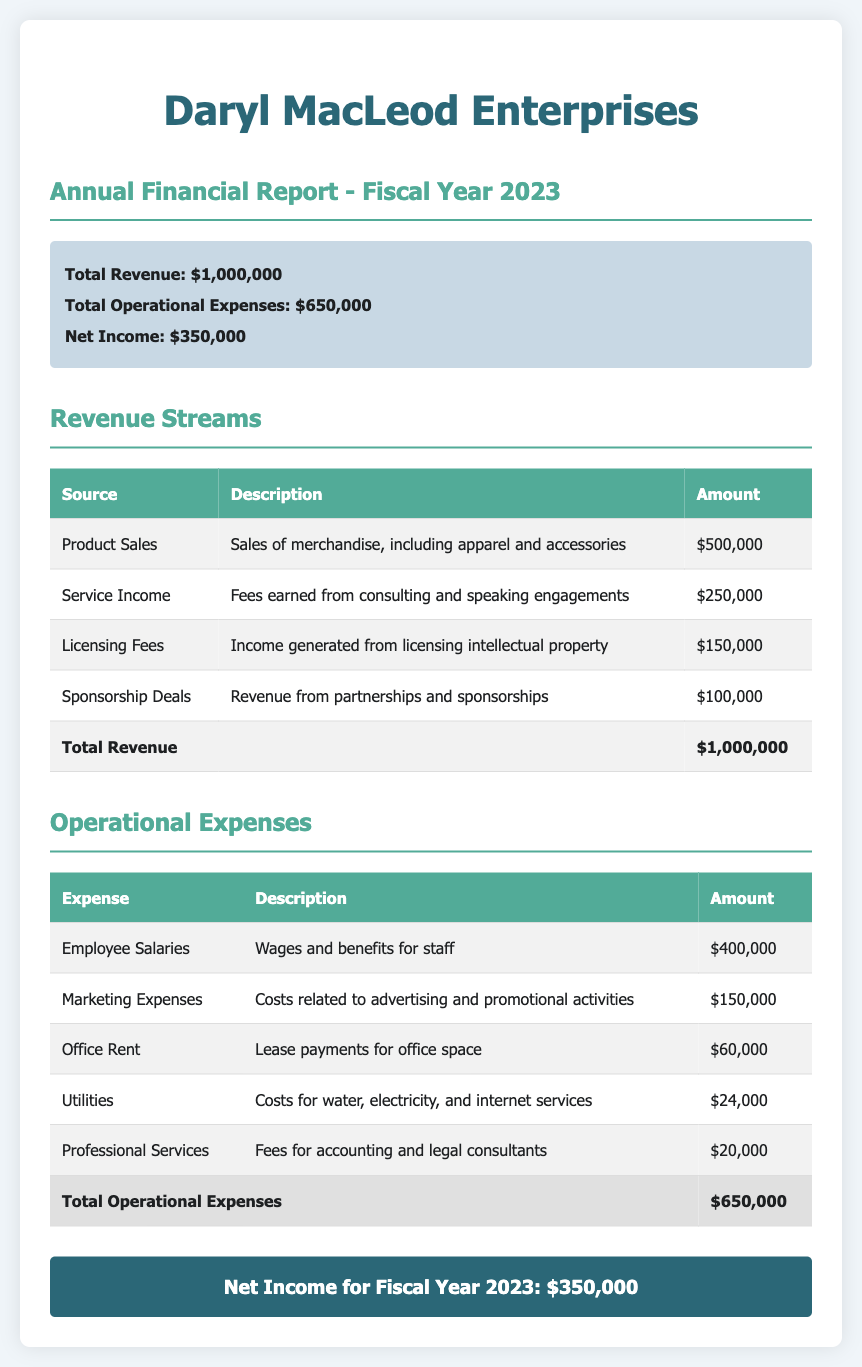What is the total revenue? The total revenue is stated in the summary section, which totals all revenue streams to $1,000,000.
Answer: $1,000,000 What is the net income for fiscal year 2023? The net income is provided in the summary section, calculated as total revenue minus total operational expenses: $1,000,000 - $650,000.
Answer: $350,000 How much was earned from product sales? The document lists the amount earned from product sales specifically as $500,000 in the revenue streams table.
Answer: $500,000 What are the total operational expenses? The total operational expenses are summed in the summary, which is the total of all operational expenses listed as $650,000.
Answer: $650,000 Which revenue stream generated the least income? According to the revenue streams table, sponsorship deals generated the least income with an amount of $100,000.
Answer: Sponsorship Deals What was the expense for marketing? The marketing expenses are listed in the operational expenses table as $150,000.
Answer: $150,000 What is the amount spent on employee salaries? The document specifies that employee salaries amount to $400,000 in the operational expenses section.
Answer: $400,000 What category of revenue makes up the largest portion? Product sales account for the largest portion of revenue, amounting to $500,000, according to the revenue streams table.
Answer: Product Sales What is the description of licensing fees? The document describes licensing fees as income generated from licensing intellectual property in the revenue streams section.
Answer: Income generated from licensing intellectual property 